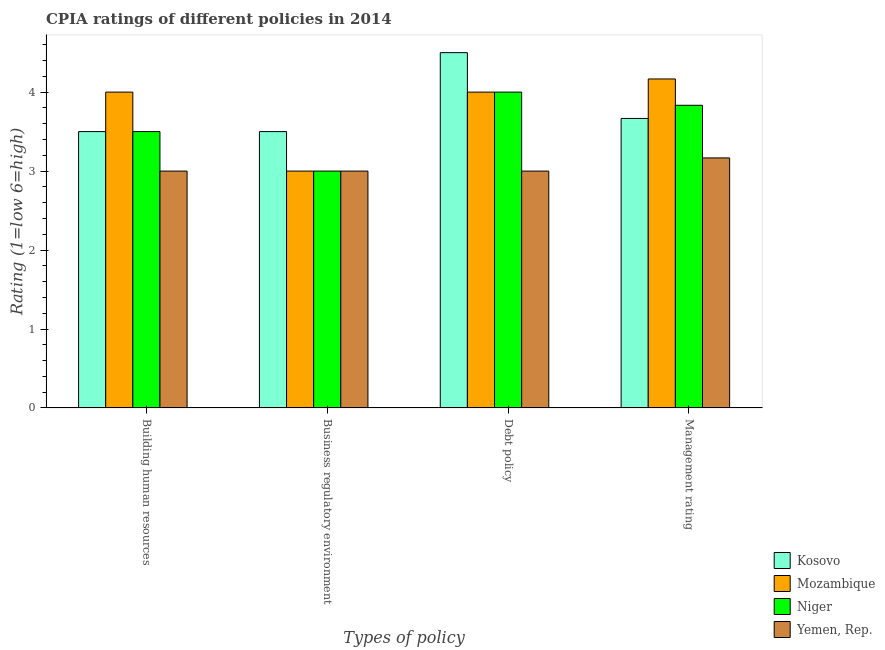How many different coloured bars are there?
Keep it short and to the point. 4. What is the label of the 3rd group of bars from the left?
Ensure brevity in your answer.  Debt policy. What is the cpia rating of management in Yemen, Rep.?
Provide a short and direct response. 3.17. Across all countries, what is the maximum cpia rating of management?
Provide a short and direct response. 4.17. Across all countries, what is the minimum cpia rating of business regulatory environment?
Your answer should be very brief. 3. In which country was the cpia rating of business regulatory environment maximum?
Offer a terse response. Kosovo. In which country was the cpia rating of management minimum?
Provide a short and direct response. Yemen, Rep. What is the average cpia rating of debt policy per country?
Offer a terse response. 3.88. What is the difference between the cpia rating of business regulatory environment and cpia rating of management in Niger?
Offer a terse response. -0.83. In how many countries, is the cpia rating of business regulatory environment greater than 2.2 ?
Ensure brevity in your answer.  4. What is the ratio of the cpia rating of management in Kosovo to that in Niger?
Your answer should be compact. 0.96. Is the difference between the cpia rating of business regulatory environment in Yemen, Rep. and Kosovo greater than the difference between the cpia rating of debt policy in Yemen, Rep. and Kosovo?
Your answer should be compact. Yes. What is the difference between the highest and the lowest cpia rating of business regulatory environment?
Your answer should be compact. 0.5. In how many countries, is the cpia rating of building human resources greater than the average cpia rating of building human resources taken over all countries?
Give a very brief answer. 1. Is it the case that in every country, the sum of the cpia rating of business regulatory environment and cpia rating of debt policy is greater than the sum of cpia rating of building human resources and cpia rating of management?
Offer a terse response. No. What does the 1st bar from the left in Management rating represents?
Give a very brief answer. Kosovo. What does the 2nd bar from the right in Building human resources represents?
Provide a short and direct response. Niger. Is it the case that in every country, the sum of the cpia rating of building human resources and cpia rating of business regulatory environment is greater than the cpia rating of debt policy?
Provide a short and direct response. Yes. Are all the bars in the graph horizontal?
Make the answer very short. No. Are the values on the major ticks of Y-axis written in scientific E-notation?
Give a very brief answer. No. How many legend labels are there?
Ensure brevity in your answer.  4. What is the title of the graph?
Give a very brief answer. CPIA ratings of different policies in 2014. What is the label or title of the X-axis?
Ensure brevity in your answer.  Types of policy. What is the Rating (1=low 6=high) of Kosovo in Building human resources?
Your answer should be compact. 3.5. What is the Rating (1=low 6=high) in Niger in Building human resources?
Your answer should be compact. 3.5. What is the Rating (1=low 6=high) in Mozambique in Business regulatory environment?
Offer a terse response. 3. What is the Rating (1=low 6=high) in Niger in Business regulatory environment?
Make the answer very short. 3. What is the Rating (1=low 6=high) in Yemen, Rep. in Business regulatory environment?
Your answer should be compact. 3. What is the Rating (1=low 6=high) in Mozambique in Debt policy?
Provide a short and direct response. 4. What is the Rating (1=low 6=high) of Niger in Debt policy?
Keep it short and to the point. 4. What is the Rating (1=low 6=high) of Yemen, Rep. in Debt policy?
Your response must be concise. 3. What is the Rating (1=low 6=high) in Kosovo in Management rating?
Give a very brief answer. 3.67. What is the Rating (1=low 6=high) in Mozambique in Management rating?
Your answer should be compact. 4.17. What is the Rating (1=low 6=high) in Niger in Management rating?
Your answer should be compact. 3.83. What is the Rating (1=low 6=high) of Yemen, Rep. in Management rating?
Provide a short and direct response. 3.17. Across all Types of policy, what is the maximum Rating (1=low 6=high) in Kosovo?
Keep it short and to the point. 4.5. Across all Types of policy, what is the maximum Rating (1=low 6=high) in Mozambique?
Provide a succinct answer. 4.17. Across all Types of policy, what is the maximum Rating (1=low 6=high) of Yemen, Rep.?
Provide a succinct answer. 3.17. Across all Types of policy, what is the minimum Rating (1=low 6=high) of Mozambique?
Your response must be concise. 3. Across all Types of policy, what is the minimum Rating (1=low 6=high) of Yemen, Rep.?
Your answer should be compact. 3. What is the total Rating (1=low 6=high) of Kosovo in the graph?
Your answer should be compact. 15.17. What is the total Rating (1=low 6=high) in Mozambique in the graph?
Offer a terse response. 15.17. What is the total Rating (1=low 6=high) of Niger in the graph?
Keep it short and to the point. 14.33. What is the total Rating (1=low 6=high) in Yemen, Rep. in the graph?
Provide a short and direct response. 12.17. What is the difference between the Rating (1=low 6=high) of Kosovo in Building human resources and that in Business regulatory environment?
Offer a terse response. 0. What is the difference between the Rating (1=low 6=high) in Kosovo in Building human resources and that in Debt policy?
Provide a short and direct response. -1. What is the difference between the Rating (1=low 6=high) of Niger in Building human resources and that in Debt policy?
Give a very brief answer. -0.5. What is the difference between the Rating (1=low 6=high) in Yemen, Rep. in Building human resources and that in Debt policy?
Provide a succinct answer. 0. What is the difference between the Rating (1=low 6=high) in Mozambique in Building human resources and that in Management rating?
Provide a succinct answer. -0.17. What is the difference between the Rating (1=low 6=high) of Kosovo in Business regulatory environment and that in Debt policy?
Offer a very short reply. -1. What is the difference between the Rating (1=low 6=high) of Mozambique in Business regulatory environment and that in Debt policy?
Keep it short and to the point. -1. What is the difference between the Rating (1=low 6=high) in Niger in Business regulatory environment and that in Debt policy?
Ensure brevity in your answer.  -1. What is the difference between the Rating (1=low 6=high) of Mozambique in Business regulatory environment and that in Management rating?
Offer a terse response. -1.17. What is the difference between the Rating (1=low 6=high) of Niger in Business regulatory environment and that in Management rating?
Provide a succinct answer. -0.83. What is the difference between the Rating (1=low 6=high) in Yemen, Rep. in Business regulatory environment and that in Management rating?
Offer a very short reply. -0.17. What is the difference between the Rating (1=low 6=high) of Kosovo in Debt policy and that in Management rating?
Your answer should be very brief. 0.83. What is the difference between the Rating (1=low 6=high) in Mozambique in Debt policy and that in Management rating?
Provide a succinct answer. -0.17. What is the difference between the Rating (1=low 6=high) in Yemen, Rep. in Debt policy and that in Management rating?
Your response must be concise. -0.17. What is the difference between the Rating (1=low 6=high) of Mozambique in Building human resources and the Rating (1=low 6=high) of Niger in Business regulatory environment?
Keep it short and to the point. 1. What is the difference between the Rating (1=low 6=high) of Kosovo in Building human resources and the Rating (1=low 6=high) of Mozambique in Debt policy?
Give a very brief answer. -0.5. What is the difference between the Rating (1=low 6=high) of Kosovo in Building human resources and the Rating (1=low 6=high) of Niger in Debt policy?
Give a very brief answer. -0.5. What is the difference between the Rating (1=low 6=high) in Kosovo in Building human resources and the Rating (1=low 6=high) in Yemen, Rep. in Debt policy?
Ensure brevity in your answer.  0.5. What is the difference between the Rating (1=low 6=high) of Mozambique in Building human resources and the Rating (1=low 6=high) of Niger in Debt policy?
Provide a succinct answer. 0. What is the difference between the Rating (1=low 6=high) of Mozambique in Building human resources and the Rating (1=low 6=high) of Yemen, Rep. in Debt policy?
Make the answer very short. 1. What is the difference between the Rating (1=low 6=high) in Niger in Building human resources and the Rating (1=low 6=high) in Yemen, Rep. in Debt policy?
Provide a short and direct response. 0.5. What is the difference between the Rating (1=low 6=high) in Kosovo in Building human resources and the Rating (1=low 6=high) in Niger in Management rating?
Offer a very short reply. -0.33. What is the difference between the Rating (1=low 6=high) in Mozambique in Building human resources and the Rating (1=low 6=high) in Niger in Management rating?
Your answer should be very brief. 0.17. What is the difference between the Rating (1=low 6=high) in Mozambique in Building human resources and the Rating (1=low 6=high) in Yemen, Rep. in Management rating?
Offer a terse response. 0.83. What is the difference between the Rating (1=low 6=high) in Kosovo in Business regulatory environment and the Rating (1=low 6=high) in Niger in Debt policy?
Your response must be concise. -0.5. What is the difference between the Rating (1=low 6=high) of Kosovo in Business regulatory environment and the Rating (1=low 6=high) of Yemen, Rep. in Debt policy?
Your response must be concise. 0.5. What is the difference between the Rating (1=low 6=high) of Mozambique in Business regulatory environment and the Rating (1=low 6=high) of Niger in Debt policy?
Keep it short and to the point. -1. What is the difference between the Rating (1=low 6=high) of Niger in Business regulatory environment and the Rating (1=low 6=high) of Yemen, Rep. in Debt policy?
Offer a very short reply. 0. What is the difference between the Rating (1=low 6=high) in Kosovo in Business regulatory environment and the Rating (1=low 6=high) in Yemen, Rep. in Management rating?
Your answer should be very brief. 0.33. What is the difference between the Rating (1=low 6=high) of Mozambique in Business regulatory environment and the Rating (1=low 6=high) of Yemen, Rep. in Management rating?
Provide a short and direct response. -0.17. What is the difference between the Rating (1=low 6=high) in Kosovo in Debt policy and the Rating (1=low 6=high) in Yemen, Rep. in Management rating?
Provide a short and direct response. 1.33. What is the difference between the Rating (1=low 6=high) in Mozambique in Debt policy and the Rating (1=low 6=high) in Yemen, Rep. in Management rating?
Your answer should be compact. 0.83. What is the difference between the Rating (1=low 6=high) of Niger in Debt policy and the Rating (1=low 6=high) of Yemen, Rep. in Management rating?
Give a very brief answer. 0.83. What is the average Rating (1=low 6=high) of Kosovo per Types of policy?
Give a very brief answer. 3.79. What is the average Rating (1=low 6=high) in Mozambique per Types of policy?
Provide a succinct answer. 3.79. What is the average Rating (1=low 6=high) of Niger per Types of policy?
Make the answer very short. 3.58. What is the average Rating (1=low 6=high) in Yemen, Rep. per Types of policy?
Provide a short and direct response. 3.04. What is the difference between the Rating (1=low 6=high) in Kosovo and Rating (1=low 6=high) in Niger in Building human resources?
Provide a short and direct response. 0. What is the difference between the Rating (1=low 6=high) in Mozambique and Rating (1=low 6=high) in Yemen, Rep. in Building human resources?
Provide a short and direct response. 1. What is the difference between the Rating (1=low 6=high) of Kosovo and Rating (1=low 6=high) of Yemen, Rep. in Business regulatory environment?
Keep it short and to the point. 0.5. What is the difference between the Rating (1=low 6=high) in Mozambique and Rating (1=low 6=high) in Yemen, Rep. in Debt policy?
Your response must be concise. 1. What is the difference between the Rating (1=low 6=high) of Kosovo and Rating (1=low 6=high) of Mozambique in Management rating?
Your answer should be very brief. -0.5. What is the difference between the Rating (1=low 6=high) of Kosovo and Rating (1=low 6=high) of Niger in Management rating?
Give a very brief answer. -0.17. What is the difference between the Rating (1=low 6=high) in Mozambique and Rating (1=low 6=high) in Niger in Management rating?
Provide a short and direct response. 0.33. What is the ratio of the Rating (1=low 6=high) of Niger in Building human resources to that in Business regulatory environment?
Keep it short and to the point. 1.17. What is the ratio of the Rating (1=low 6=high) of Niger in Building human resources to that in Debt policy?
Make the answer very short. 0.88. What is the ratio of the Rating (1=low 6=high) in Yemen, Rep. in Building human resources to that in Debt policy?
Ensure brevity in your answer.  1. What is the ratio of the Rating (1=low 6=high) of Kosovo in Building human resources to that in Management rating?
Make the answer very short. 0.95. What is the ratio of the Rating (1=low 6=high) in Mozambique in Building human resources to that in Management rating?
Make the answer very short. 0.96. What is the ratio of the Rating (1=low 6=high) of Niger in Building human resources to that in Management rating?
Ensure brevity in your answer.  0.91. What is the ratio of the Rating (1=low 6=high) in Yemen, Rep. in Building human resources to that in Management rating?
Your answer should be compact. 0.95. What is the ratio of the Rating (1=low 6=high) in Mozambique in Business regulatory environment to that in Debt policy?
Offer a terse response. 0.75. What is the ratio of the Rating (1=low 6=high) of Niger in Business regulatory environment to that in Debt policy?
Give a very brief answer. 0.75. What is the ratio of the Rating (1=low 6=high) of Kosovo in Business regulatory environment to that in Management rating?
Offer a terse response. 0.95. What is the ratio of the Rating (1=low 6=high) in Mozambique in Business regulatory environment to that in Management rating?
Your answer should be very brief. 0.72. What is the ratio of the Rating (1=low 6=high) in Niger in Business regulatory environment to that in Management rating?
Give a very brief answer. 0.78. What is the ratio of the Rating (1=low 6=high) of Kosovo in Debt policy to that in Management rating?
Your response must be concise. 1.23. What is the ratio of the Rating (1=low 6=high) in Niger in Debt policy to that in Management rating?
Give a very brief answer. 1.04. What is the ratio of the Rating (1=low 6=high) of Yemen, Rep. in Debt policy to that in Management rating?
Provide a succinct answer. 0.95. What is the difference between the highest and the second highest Rating (1=low 6=high) of Mozambique?
Provide a succinct answer. 0.17. What is the difference between the highest and the second highest Rating (1=low 6=high) in Niger?
Your response must be concise. 0.17. What is the difference between the highest and the second highest Rating (1=low 6=high) of Yemen, Rep.?
Ensure brevity in your answer.  0.17. What is the difference between the highest and the lowest Rating (1=low 6=high) in Mozambique?
Make the answer very short. 1.17. What is the difference between the highest and the lowest Rating (1=low 6=high) of Yemen, Rep.?
Your answer should be very brief. 0.17. 